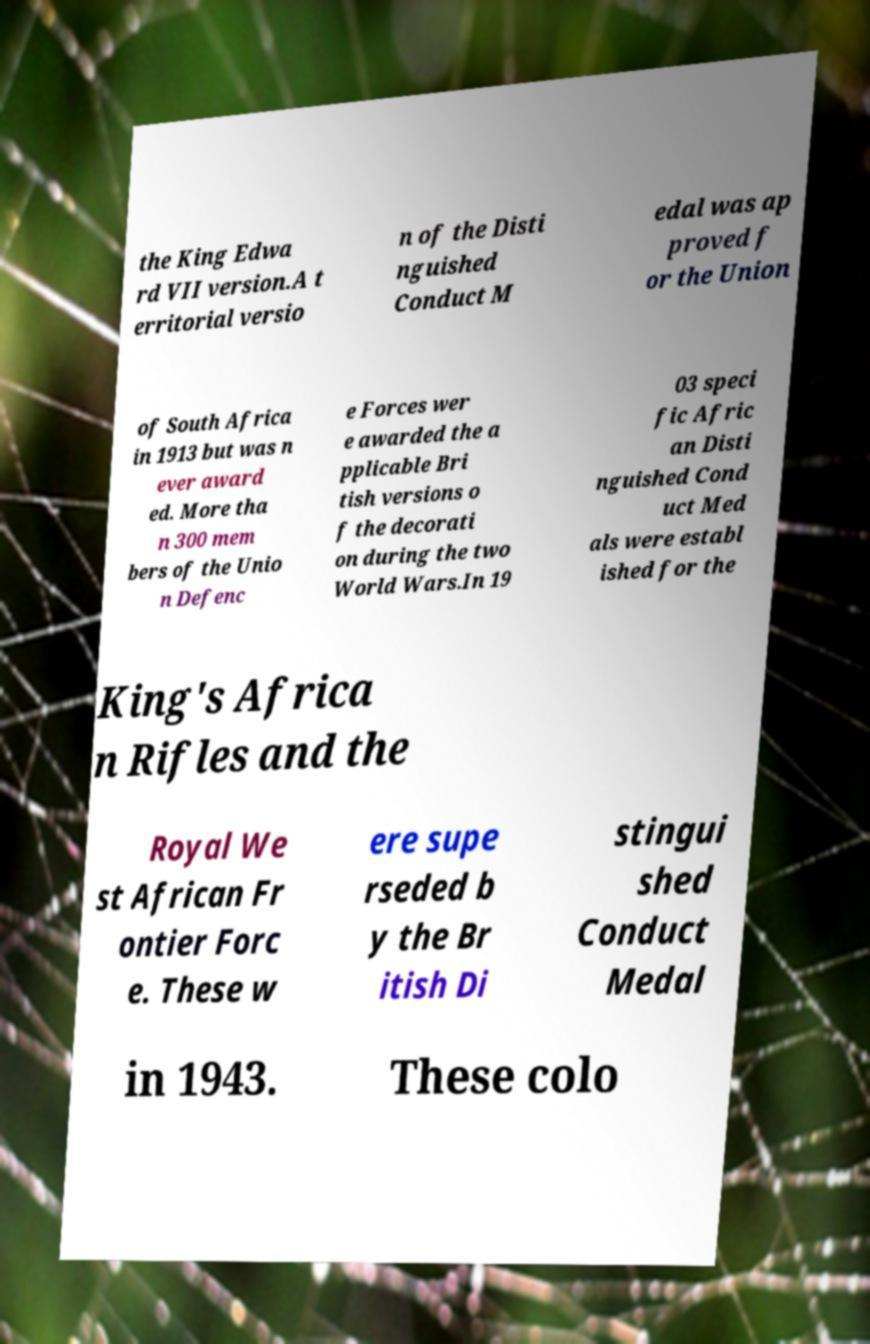For documentation purposes, I need the text within this image transcribed. Could you provide that? the King Edwa rd VII version.A t erritorial versio n of the Disti nguished Conduct M edal was ap proved f or the Union of South Africa in 1913 but was n ever award ed. More tha n 300 mem bers of the Unio n Defenc e Forces wer e awarded the a pplicable Bri tish versions o f the decorati on during the two World Wars.In 19 03 speci fic Afric an Disti nguished Cond uct Med als were establ ished for the King's Africa n Rifles and the Royal We st African Fr ontier Forc e. These w ere supe rseded b y the Br itish Di stingui shed Conduct Medal in 1943. These colo 